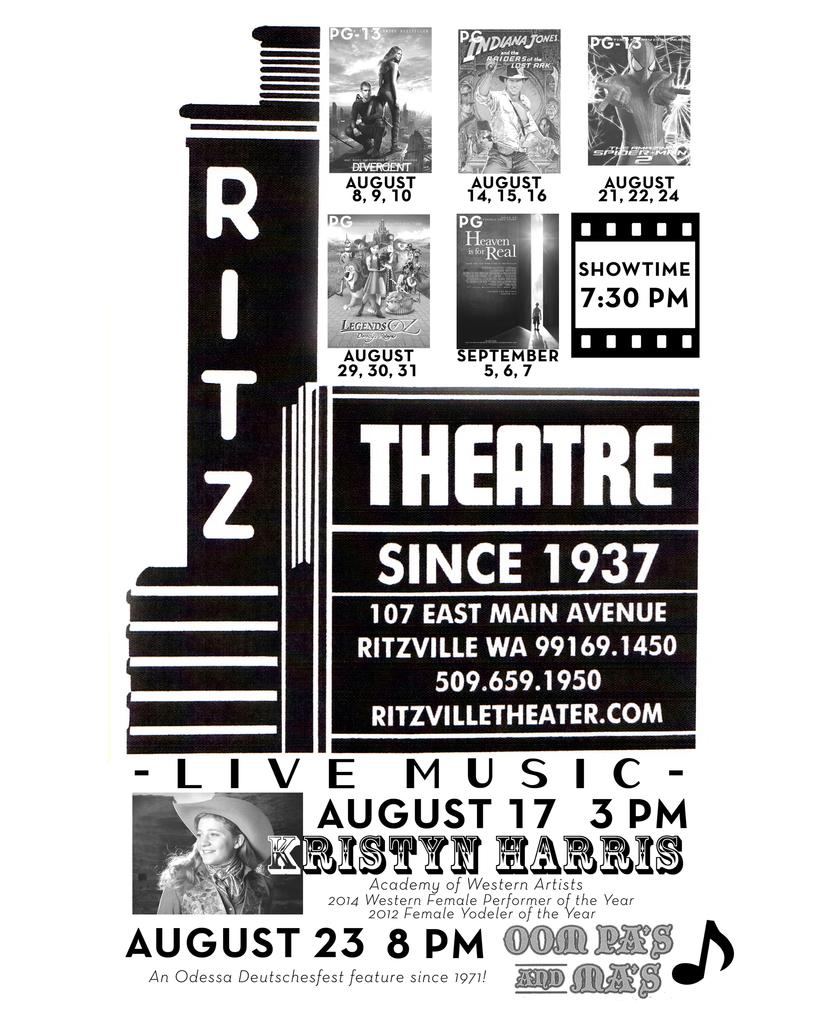Provide a one-sentence caption for the provided image. August and early September showtimes are displayed for the Ritz theatre. 